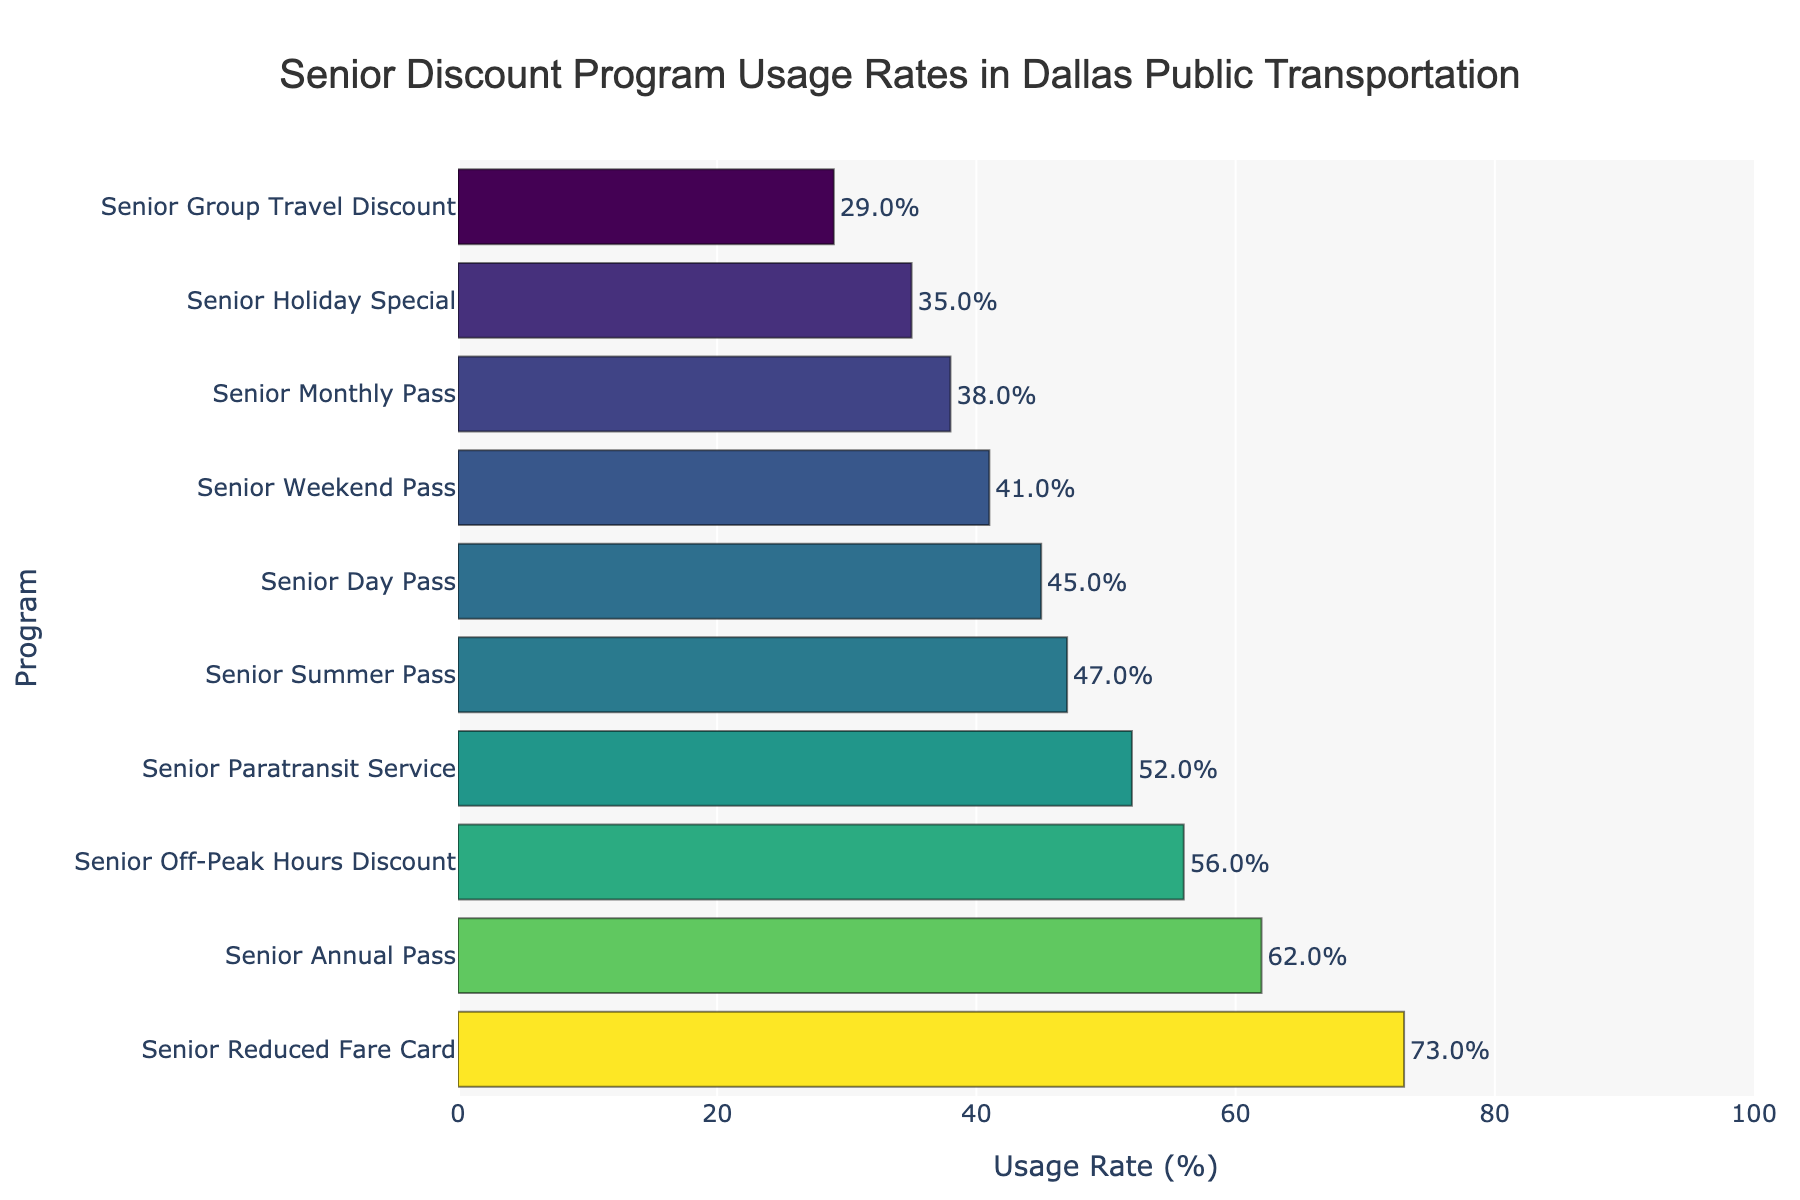What is the usage rate of the Senior Reduced Fare Card? The Senior Reduced Fare Card's usage rate can be found directly by looking at the bar labeled "Senior Reduced Fare Card."
Answer: 73% Which program has the lowest usage rate? To determine the program with the lowest usage rate, find the shortest bar or the bar with the smallest value.
Answer: Senior Group Travel Discount What is the difference in usage rates between the Senior Annual Pass and the Senior Weekend Pass? Subtract the usage rate of the Senior Weekend Pass from the usage rate of the Senior Annual Pass: 62% - 41% = 21%.
Answer: 21% How many programs have a usage rate higher than 50%? Count the number of bars where the value is greater than 50%. The programs are: Senior Reduced Fare Card, Senior Annual Pass, Senior Off-Peak Hours Discount, and Senior Paratransit Service.
Answer: 4 Which program has a higher usage rate: Senior Summer Pass or Senior Day Pass? Compare the usage rates of the Senior Summer Pass (47%) and the Senior Day Pass (45%).
Answer: Senior Summer Pass What is the combined usage rate of the Senior Holiday Special and the Senior Weekend Pass? Add the usage rates of the Senior Holiday Special (35%) and the Senior Weekend Pass (41%): 35% + 41% = 76%.
Answer: 76% Are there more programs with usage rates above 40% or below 40%? Count the programs with usage rates above 40% (8 programs) and below 40% (2 programs).
Answer: Above 40% Which program has the second-highest usage rate? Find the bar with the second-largest value after identifying the highest one (which is the Senior Reduced Fare Card at 73%). The second highest is the Senior Annual Pass at 62%.
Answer: Senior Annual Pass What is the average usage rate of the top three programs? The top three programs are Senior Reduced Fare Card (73%), Senior Annual Pass (62%), and Senior Off-Peak Hours Discount (56%). Calculate the average: (73 + 62 + 56) / 3 = 63.7%.
Answer: 63.7% How does the usage rate of the Senior Monthly Pass compare to the Senior Paratransit Service? Compare the usage rate of the Senior Monthly Pass (38%) to the Senior Paratransit Service (52%).
Answer: Senior Paratransit Service 